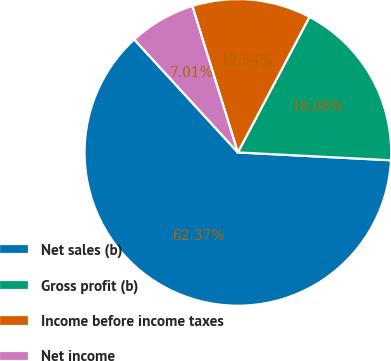<chart> <loc_0><loc_0><loc_500><loc_500><pie_chart><fcel>Net sales (b)<fcel>Gross profit (b)<fcel>Income before income taxes<fcel>Net income<nl><fcel>62.37%<fcel>18.08%<fcel>12.54%<fcel>7.01%<nl></chart> 